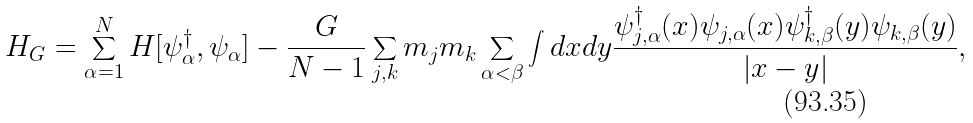Convert formula to latex. <formula><loc_0><loc_0><loc_500><loc_500>H _ { G } = \sum _ { \alpha = 1 } ^ { N } H [ \psi _ { \alpha } ^ { \dagger } , \psi _ { \alpha } ] - \frac { G } { N - 1 } \sum _ { j , k } m _ { j } m _ { k } \sum _ { \alpha < \beta } \int d x d y \frac { \psi _ { j , \alpha } ^ { \dagger } ( x ) \psi _ { j , \alpha } ( x ) \psi _ { k , \beta } ^ { \dagger } ( y ) \psi _ { k , \beta } ( y ) } { | x - y | } ,</formula> 